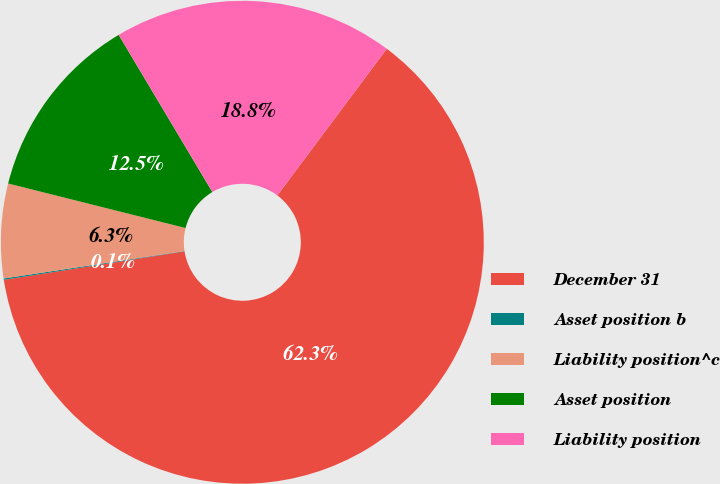Convert chart. <chart><loc_0><loc_0><loc_500><loc_500><pie_chart><fcel>December 31<fcel>Asset position b<fcel>Liability position^c<fcel>Asset position<fcel>Liability position<nl><fcel>62.3%<fcel>0.09%<fcel>6.31%<fcel>12.53%<fcel>18.76%<nl></chart> 